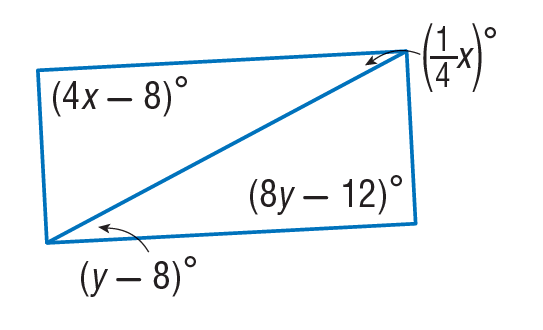Answer the mathemtical geometry problem and directly provide the correct option letter.
Question: Find y so that the quadrilateral is a parallelogram.
Choices: A: 9 B: 12 C: 15.5 D: 31 C 